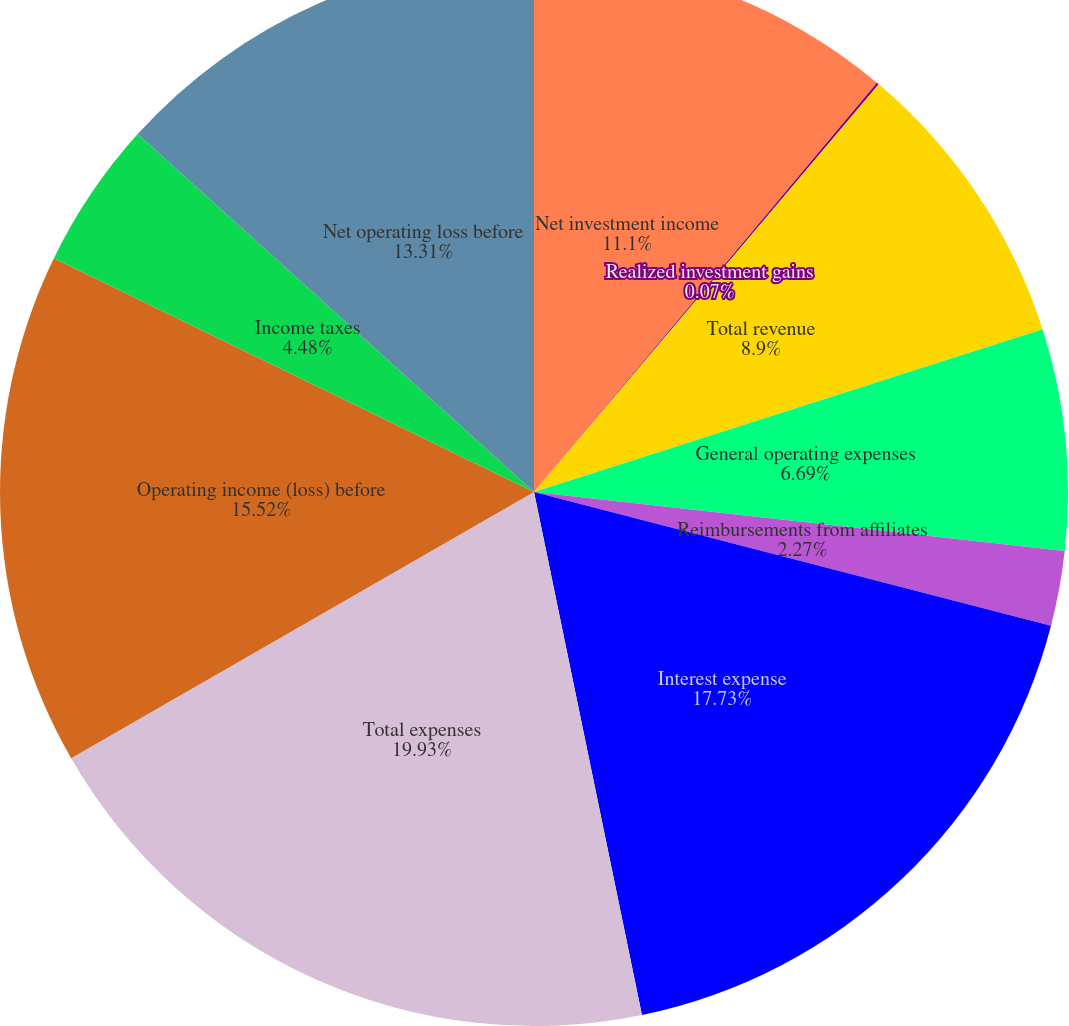Convert chart. <chart><loc_0><loc_0><loc_500><loc_500><pie_chart><fcel>Net investment income<fcel>Realized investment gains<fcel>Total revenue<fcel>General operating expenses<fcel>Reimbursements from affiliates<fcel>Interest expense<fcel>Total expenses<fcel>Operating income (loss) before<fcel>Income taxes<fcel>Net operating loss before<nl><fcel>11.1%<fcel>0.07%<fcel>8.9%<fcel>6.69%<fcel>2.27%<fcel>17.73%<fcel>19.93%<fcel>15.52%<fcel>4.48%<fcel>13.31%<nl></chart> 